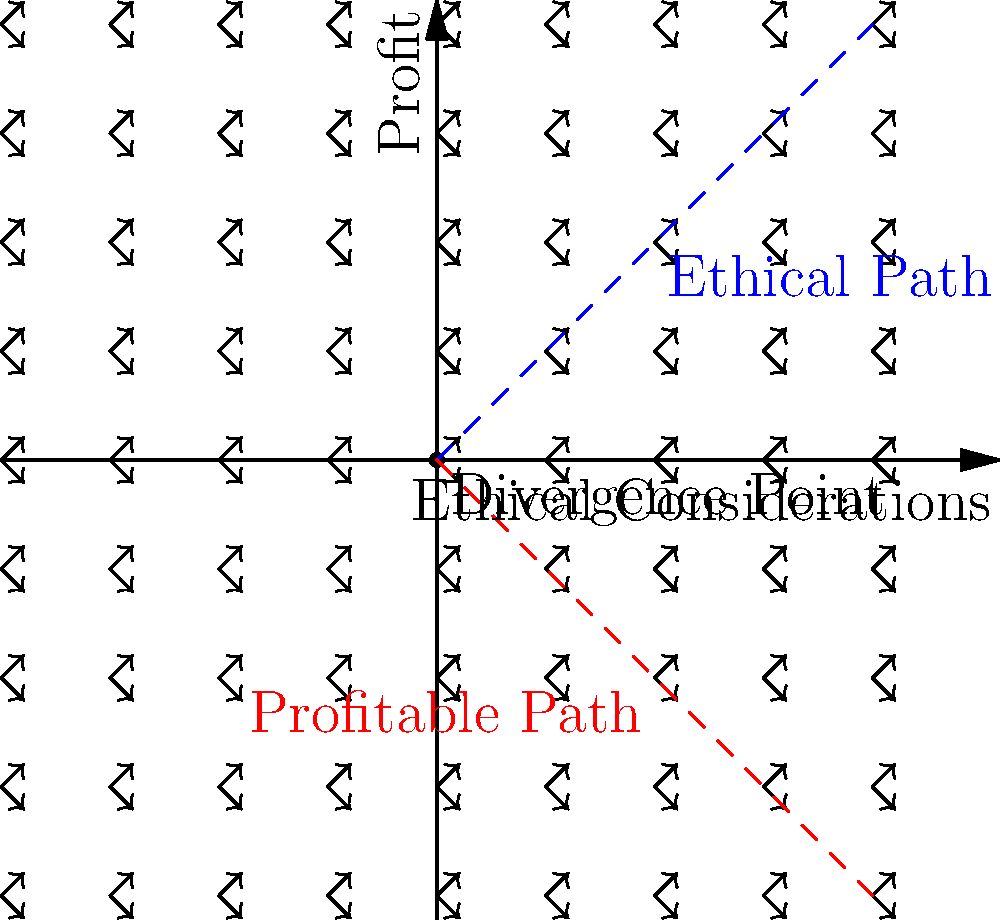In the vector field diagram representing the divergence of ethical and profitable paths in a tech company, what is the significance of the point where the two vector fields intersect, and how does it relate to the decision-making process of a company founder? To understand the significance of the intersection point and its relation to decision-making, let's analyze the diagram step-by-step:

1. Vector Fields:
   - The upward-right arrows represent the ethical considerations vector field.
   - The downward-right arrows represent the profitable actions vector field.

2. Intersection Point:
   - The point where these vector fields intersect (0,0) is labeled as the "Divergence Point."
   - This point represents the critical moment where ethical and profitable paths begin to separate.

3. Paths:
   - The blue dashed line shows the ethical path, moving upward.
   - The red dashed line shows the profitable path, moving downward.

4. Significance:
   - The divergence point signifies a crucial decision-making moment for the company founder.
   - It represents the point where ethical considerations and profit-driven actions start to conflict.

5. Decision-making Process:
   - At the divergence point, the founder must choose between following the ethical path or the profitable path.
   - This choice will significantly impact the company's future direction and values.

6. Consequences:
   - Following the ethical path may lead to slower growth but stronger long-term sustainability and reputation.
   - Choosing the profitable path might result in rapid growth but potential ethical compromises and future regrets.

7. Relation to the Persona:
   - As a successful tech entrepreneur regretting the lack of ethics in their company's early foundations, this divergence point represents the moment where critical ethical decisions were overlooked in favor of profitability.

The divergence point thus embodies the crucial moment where a founder's values and priorities are tested, setting the tone for the company's future ethical stance and business practices.
Answer: The divergence point represents the critical decision-making moment where ethical and profitable paths separate, challenging the founder to choose between ethical considerations and profit-driven actions. 